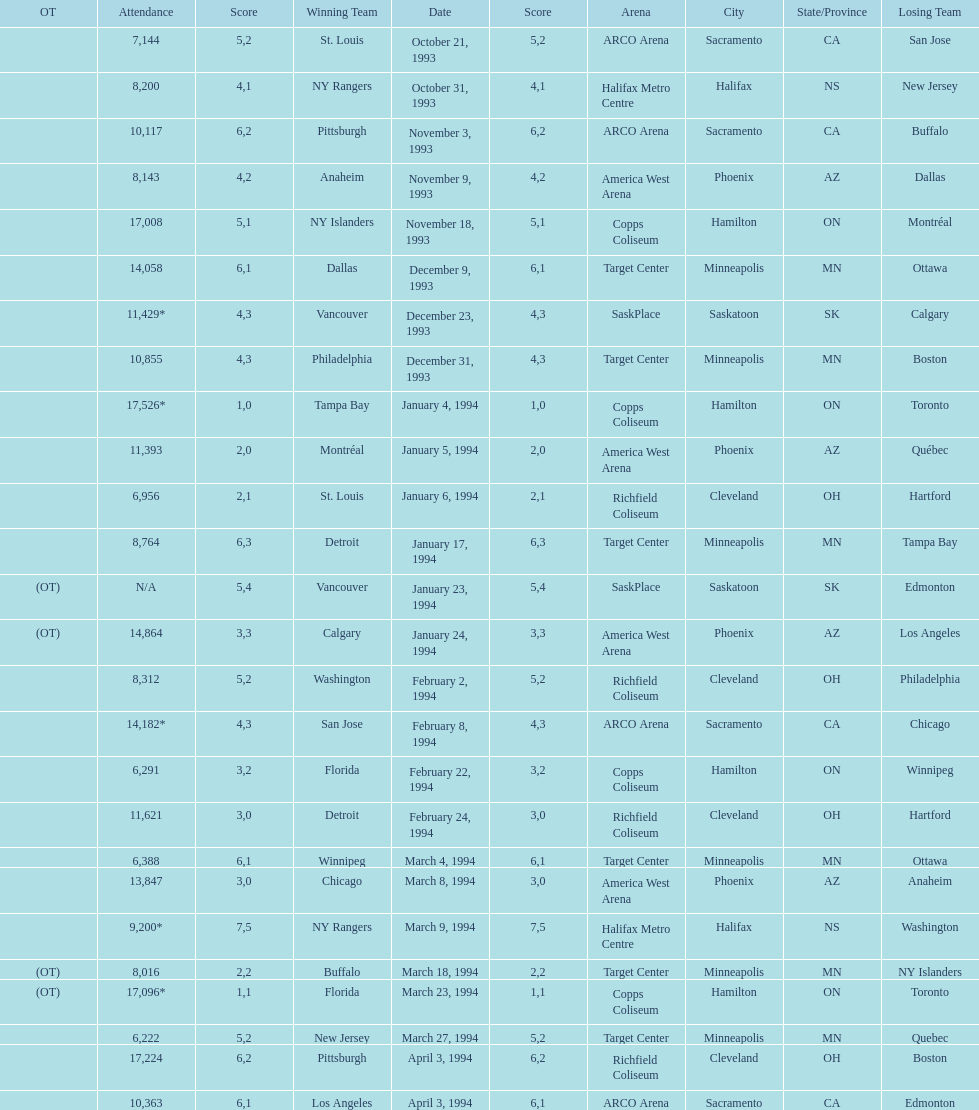When did tampa bay win their first neutral site game? January 4, 1994. I'm looking to parse the entire table for insights. Could you assist me with that? {'header': ['OT', 'Attendance', 'Score', 'Winning Team', 'Date', 'Score', 'Arena', 'City', 'State/Province', 'Losing Team'], 'rows': [['', '7,144', '5', 'St. Louis', 'October 21, 1993', '2', 'ARCO Arena', 'Sacramento', 'CA', 'San Jose'], ['', '8,200', '4', 'NY Rangers', 'October 31, 1993', '1', 'Halifax Metro Centre', 'Halifax', 'NS', 'New Jersey'], ['', '10,117', '6', 'Pittsburgh', 'November 3, 1993', '2', 'ARCO Arena', 'Sacramento', 'CA', 'Buffalo'], ['', '8,143', '4', 'Anaheim', 'November 9, 1993', '2', 'America West Arena', 'Phoenix', 'AZ', 'Dallas'], ['', '17,008', '5', 'NY Islanders', 'November 18, 1993', '1', 'Copps Coliseum', 'Hamilton', 'ON', 'Montréal'], ['', '14,058', '6', 'Dallas', 'December 9, 1993', '1', 'Target Center', 'Minneapolis', 'MN', 'Ottawa'], ['', '11,429*', '4', 'Vancouver', 'December 23, 1993', '3', 'SaskPlace', 'Saskatoon', 'SK', 'Calgary'], ['', '10,855', '4', 'Philadelphia', 'December 31, 1993', '3', 'Target Center', 'Minneapolis', 'MN', 'Boston'], ['', '17,526*', '1', 'Tampa Bay', 'January 4, 1994', '0', 'Copps Coliseum', 'Hamilton', 'ON', 'Toronto'], ['', '11,393', '2', 'Montréal', 'January 5, 1994', '0', 'America West Arena', 'Phoenix', 'AZ', 'Québec'], ['', '6,956', '2', 'St. Louis', 'January 6, 1994', '1', 'Richfield Coliseum', 'Cleveland', 'OH', 'Hartford'], ['', '8,764', '6', 'Detroit', 'January 17, 1994', '3', 'Target Center', 'Minneapolis', 'MN', 'Tampa Bay'], ['(OT)', 'N/A', '5', 'Vancouver', 'January 23, 1994', '4', 'SaskPlace', 'Saskatoon', 'SK', 'Edmonton'], ['(OT)', '14,864', '3', 'Calgary', 'January 24, 1994', '3', 'America West Arena', 'Phoenix', 'AZ', 'Los Angeles'], ['', '8,312', '5', 'Washington', 'February 2, 1994', '2', 'Richfield Coliseum', 'Cleveland', 'OH', 'Philadelphia'], ['', '14,182*', '4', 'San Jose', 'February 8, 1994', '3', 'ARCO Arena', 'Sacramento', 'CA', 'Chicago'], ['', '6,291', '3', 'Florida', 'February 22, 1994', '2', 'Copps Coliseum', 'Hamilton', 'ON', 'Winnipeg'], ['', '11,621', '3', 'Detroit', 'February 24, 1994', '0', 'Richfield Coliseum', 'Cleveland', 'OH', 'Hartford'], ['', '6,388', '6', 'Winnipeg', 'March 4, 1994', '1', 'Target Center', 'Minneapolis', 'MN', 'Ottawa'], ['', '13,847', '3', 'Chicago', 'March 8, 1994', '0', 'America West Arena', 'Phoenix', 'AZ', 'Anaheim'], ['', '9,200*', '7', 'NY Rangers', 'March 9, 1994', '5', 'Halifax Metro Centre', 'Halifax', 'NS', 'Washington'], ['(OT)', '8,016', '2', 'Buffalo', 'March 18, 1994', '2', 'Target Center', 'Minneapolis', 'MN', 'NY Islanders'], ['(OT)', '17,096*', '1', 'Florida', 'March 23, 1994', '1', 'Copps Coliseum', 'Hamilton', 'ON', 'Toronto'], ['', '6,222', '5', 'New Jersey', 'March 27, 1994', '2', 'Target Center', 'Minneapolis', 'MN', 'Quebec'], ['', '17,224', '6', 'Pittsburgh', 'April 3, 1994', '2', 'Richfield Coliseum', 'Cleveland', 'OH', 'Boston'], ['', '10,363', '6', 'Los Angeles', 'April 3, 1994', '1', 'ARCO Arena', 'Sacramento', 'CA', 'Edmonton']]} 